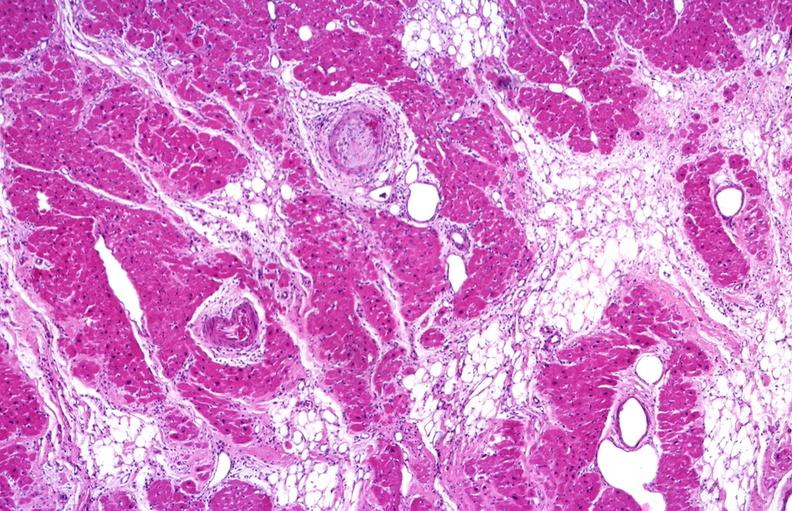where is this from?
Answer the question using a single word or phrase. Heart 